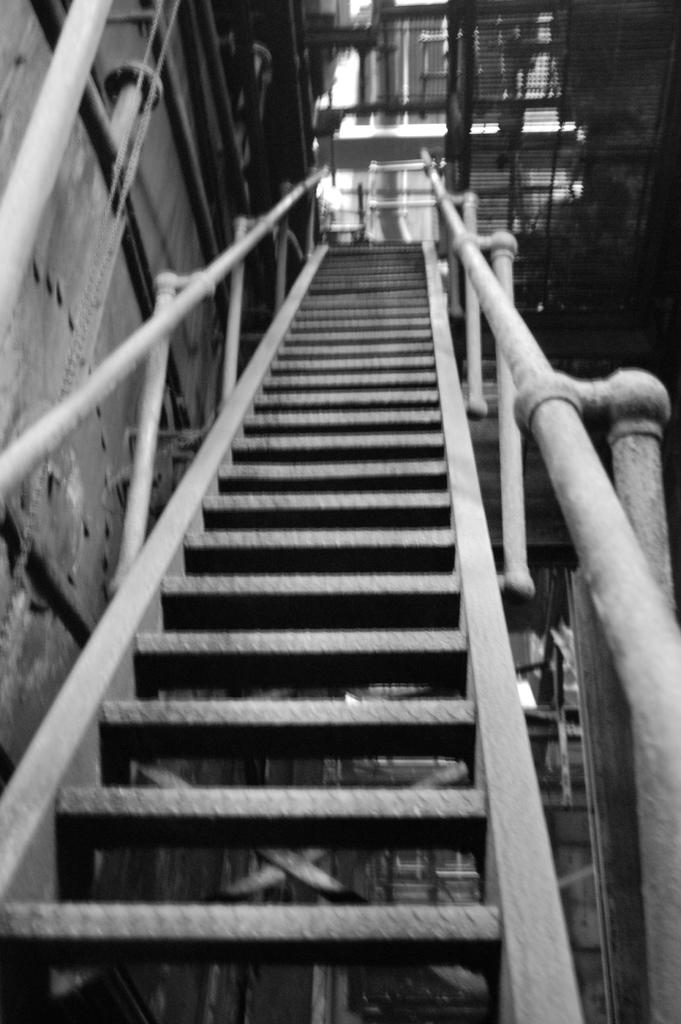What type of structure is present in the image? There is a staircase in the image. What other objects can be seen in the image? There are poles and buildings in the image. How is the image presented? The image is in black and white mode. Where is the throne located in the image? There is no throne present in the image. What type of food can be seen in the image? There is no food present in the image. 